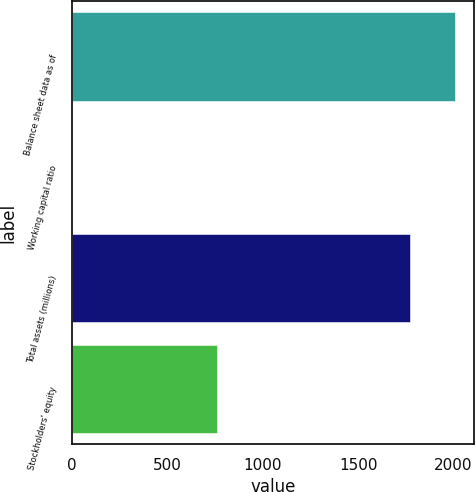Convert chart. <chart><loc_0><loc_0><loc_500><loc_500><bar_chart><fcel>Balance sheet data as of<fcel>Working capital ratio<fcel>Total assets (millions)<fcel>Stockholders' equity<nl><fcel>2006<fcel>0.98<fcel>1770<fcel>759<nl></chart> 